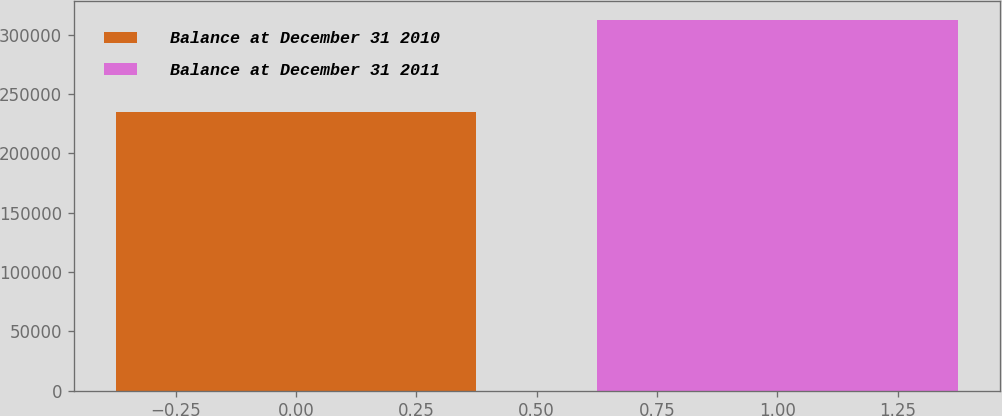Convert chart. <chart><loc_0><loc_0><loc_500><loc_500><bar_chart><fcel>Balance at December 31 2010<fcel>Balance at December 31 2011<nl><fcel>234476<fcel>312439<nl></chart> 